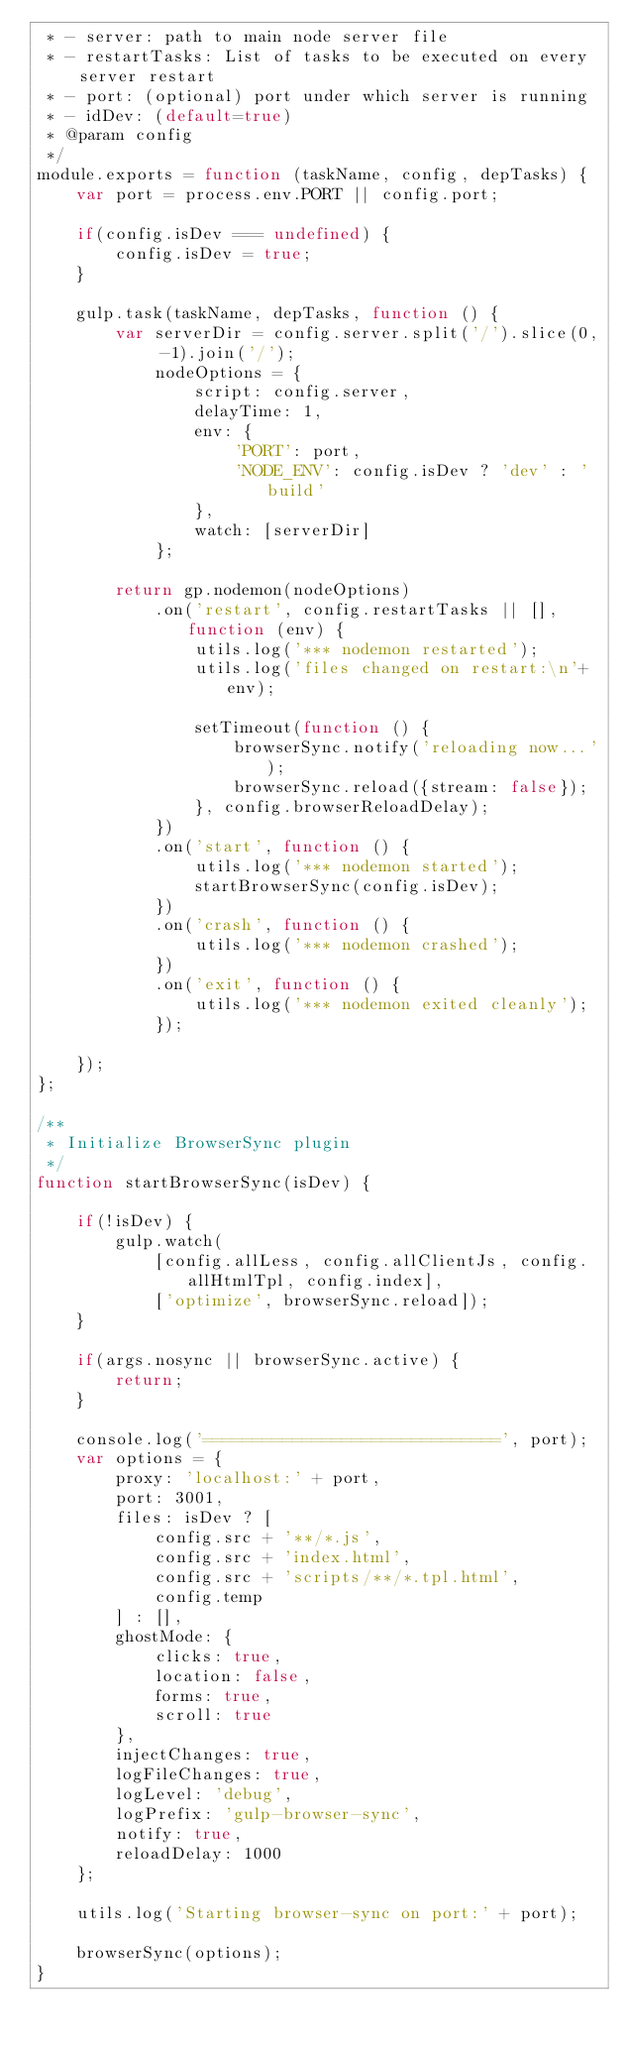Convert code to text. <code><loc_0><loc_0><loc_500><loc_500><_JavaScript_> * - server: path to main node server file
 * - restartTasks: List of tasks to be executed on every server restart
 * - port: (optional) port under which server is running
 * - idDev: (default=true)
 * @param config
 */
module.exports = function (taskName, config, depTasks) {
    var port = process.env.PORT || config.port;

    if(config.isDev === undefined) {
        config.isDev = true;
    }

    gulp.task(taskName, depTasks, function () {
        var serverDir = config.server.split('/').slice(0, -1).join('/');
            nodeOptions = {
                script: config.server,
                delayTime: 1,
                env: {
                    'PORT': port,
                    'NODE_ENV': config.isDev ? 'dev' : 'build'
                },
                watch: [serverDir]
            };

        return gp.nodemon(nodeOptions)
            .on('restart', config.restartTasks || [], function (env) {
                utils.log('*** nodemon restarted');
                utils.log('files changed on restart:\n'+env);

                setTimeout(function () {
                    browserSync.notify('reloading now...');
                    browserSync.reload({stream: false});
                }, config.browserReloadDelay);
            })
            .on('start', function () {
                utils.log('*** nodemon started');
                startBrowserSync(config.isDev);
            })
            .on('crash', function () {
                utils.log('*** nodemon crashed');
            })
            .on('exit', function () {
                utils.log('*** nodemon exited cleanly');
            });

    });
};

/**
 * Initialize BrowserSync plugin
 */
function startBrowserSync(isDev) {

    if(!isDev) {
        gulp.watch(
            [config.allLess, config.allClientJs, config.allHtmlTpl, config.index],
            ['optimize', browserSync.reload]);
    }

    if(args.nosync || browserSync.active) {
        return;
    }

    console.log('==============================', port);
    var options = {
        proxy: 'localhost:' + port,
        port: 3001,
        files: isDev ? [
            config.src + '**/*.js',
            config.src + 'index.html',
            config.src + 'scripts/**/*.tpl.html',
            config.temp
        ] : [],
        ghostMode: {
            clicks: true,
            location: false,
            forms: true,
            scroll: true
        },
        injectChanges: true,
        logFileChanges: true,
        logLevel: 'debug',
        logPrefix: 'gulp-browser-sync',
        notify: true,
        reloadDelay: 1000
    };

    utils.log('Starting browser-sync on port:' + port);

    browserSync(options);
}</code> 